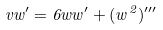Convert formula to latex. <formula><loc_0><loc_0><loc_500><loc_500>v w ^ { \prime } = 6 w w ^ { \prime } + ( w ^ { 2 } ) ^ { \prime \prime \prime }</formula> 